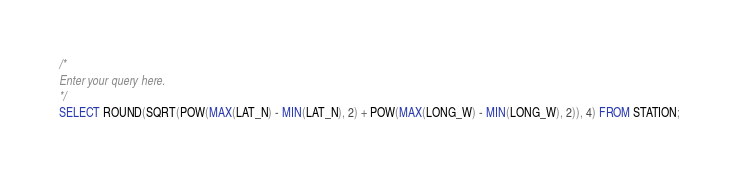<code> <loc_0><loc_0><loc_500><loc_500><_SQL_>/*
Enter your query here.
*/
SELECT ROUND(SQRT(POW(MAX(LAT_N) - MIN(LAT_N), 2) + POW(MAX(LONG_W) - MIN(LONG_W), 2)), 4) FROM STATION;
</code> 